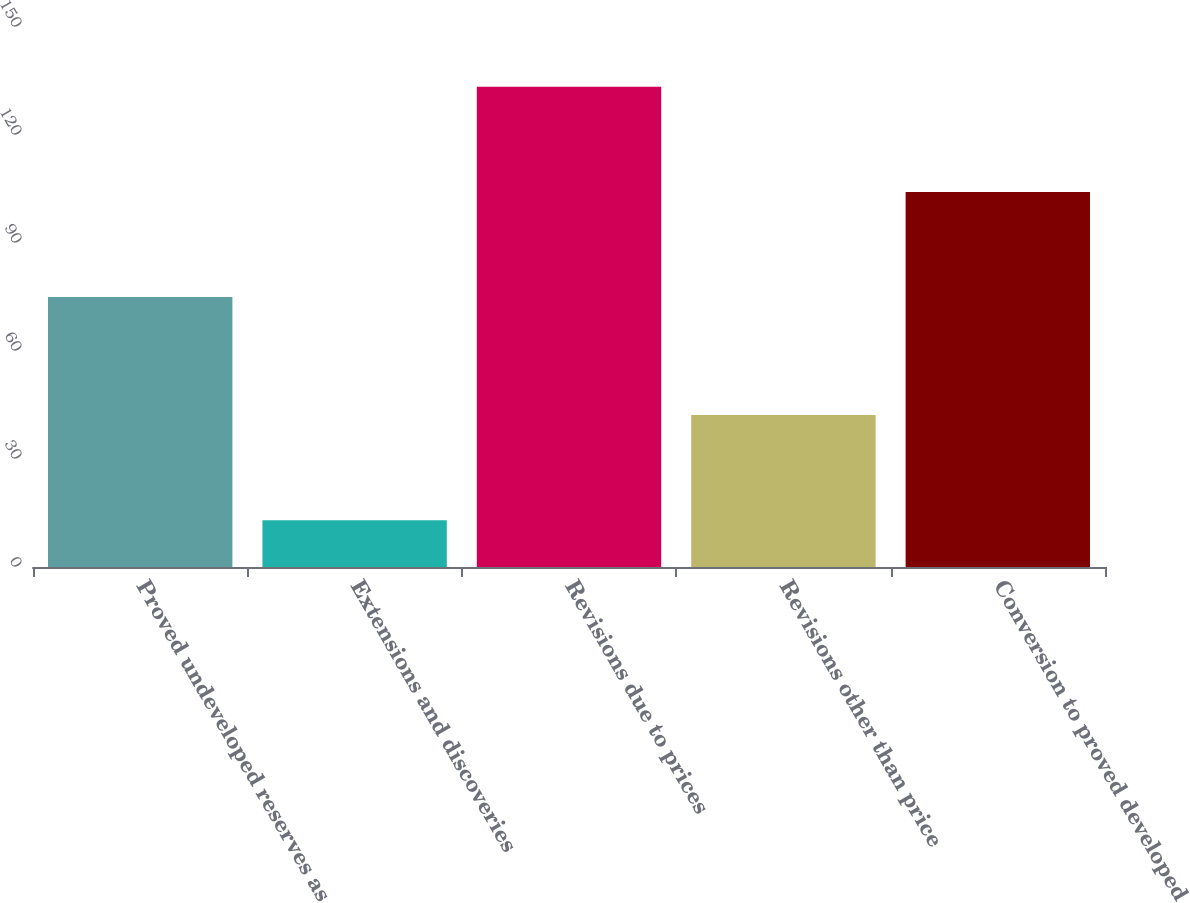<chart> <loc_0><loc_0><loc_500><loc_500><bar_chart><fcel>Proved undeveloped reserves as<fcel>Extensions and discoveries<fcel>Revisions due to prices<fcel>Revisions other than price<fcel>Conversion to proved developed<nl><fcel>75<fcel>13<fcel>133.4<fcel>42.2<fcel>104.2<nl></chart> 